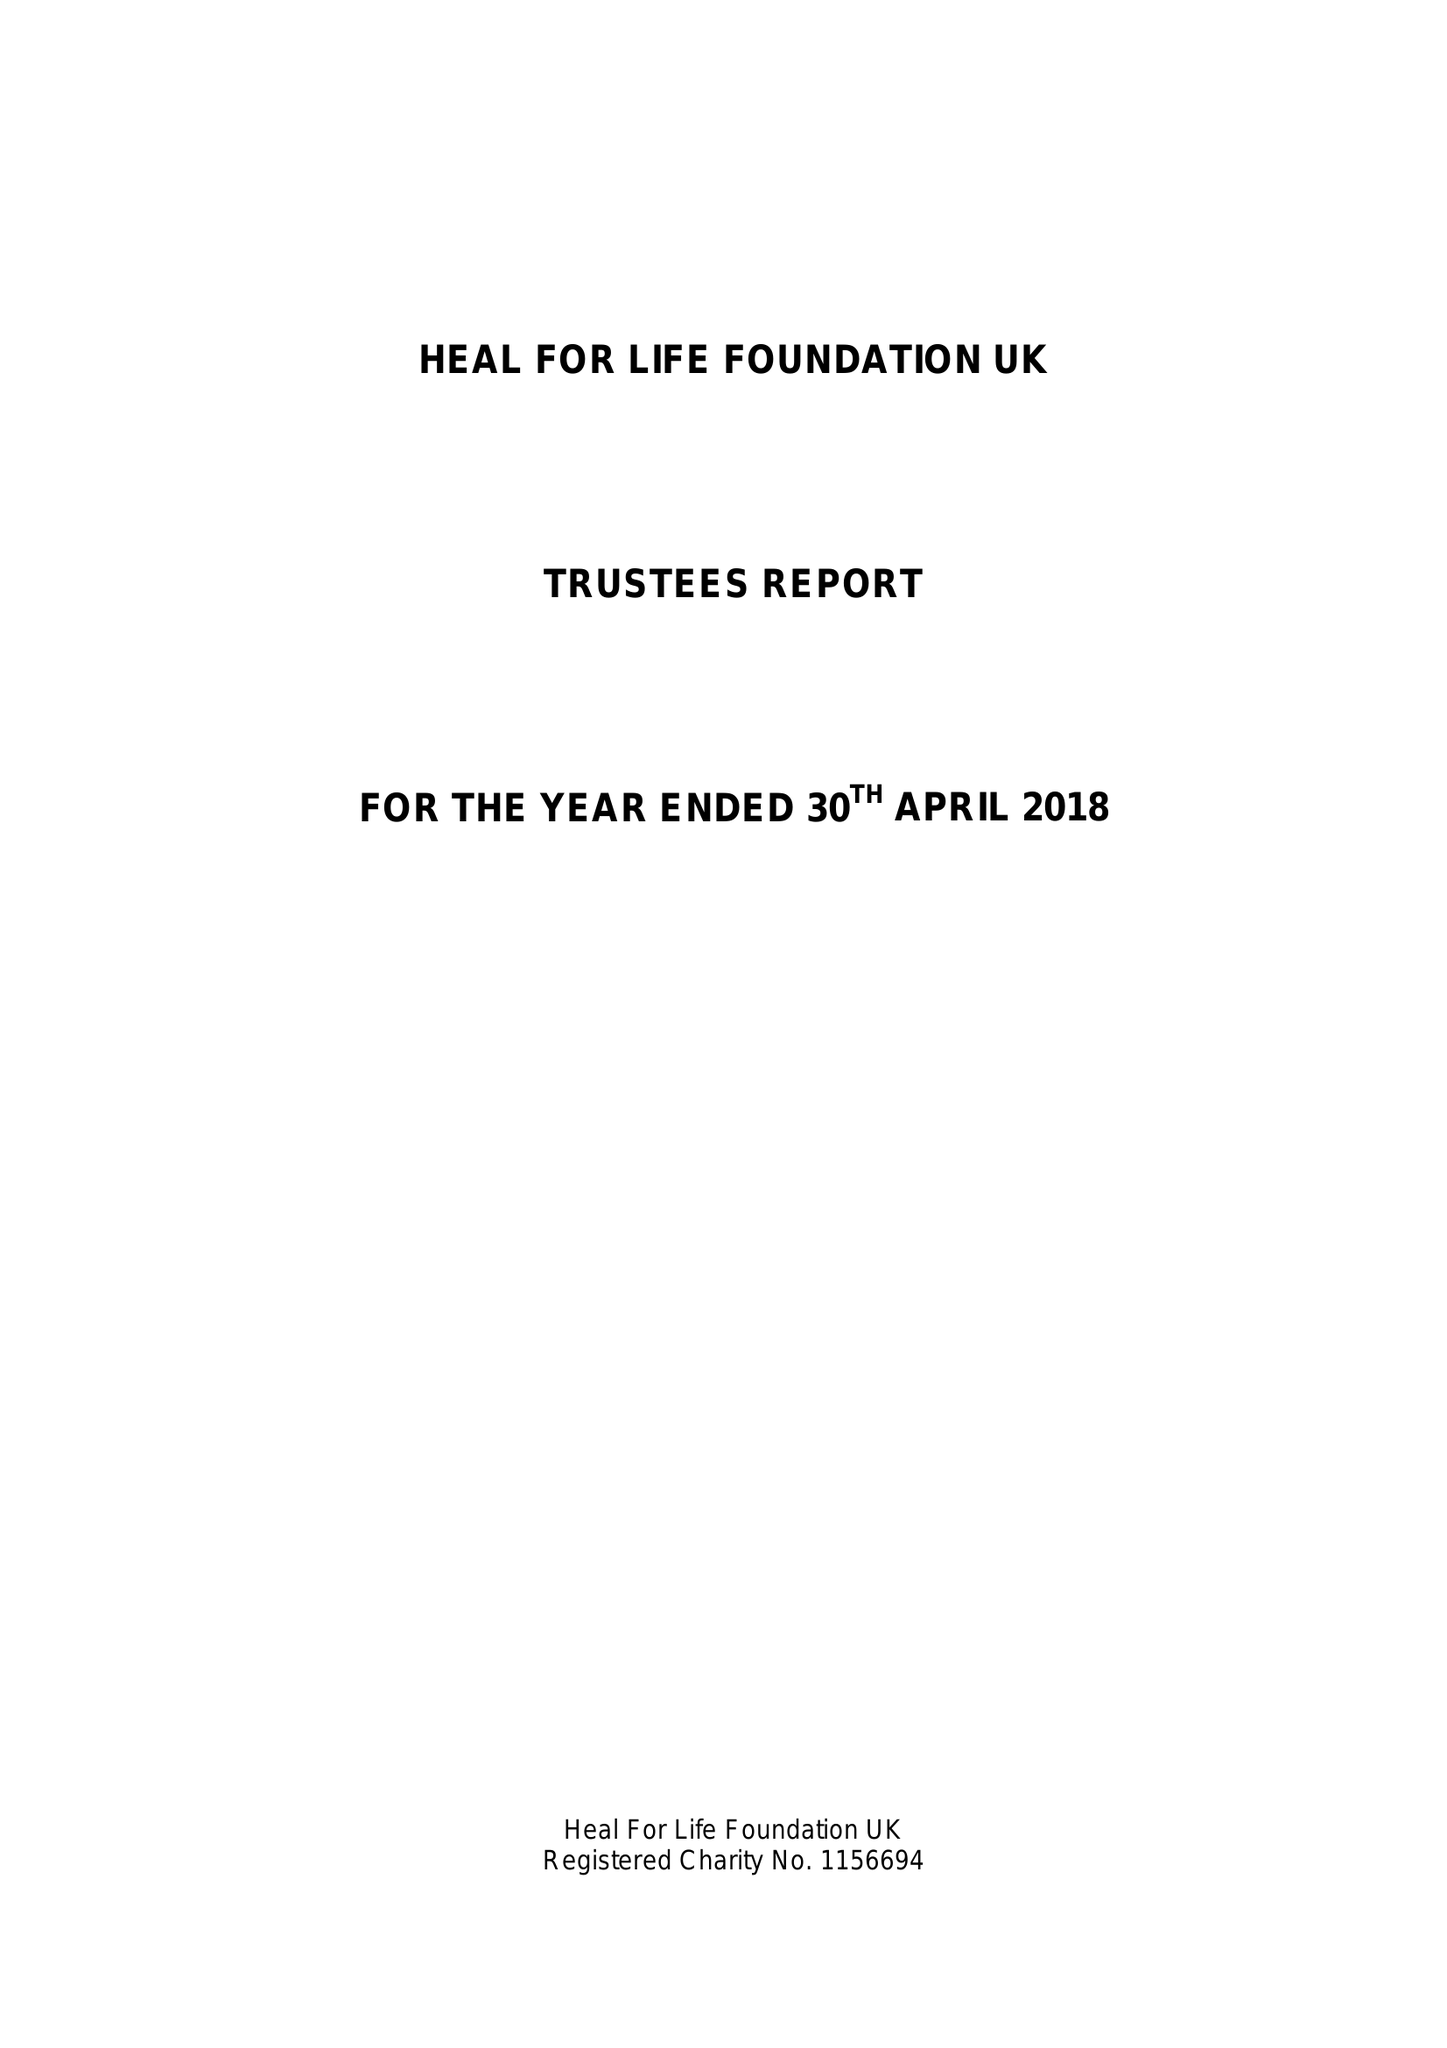What is the value for the report_date?
Answer the question using a single word or phrase. 2018-04-30 